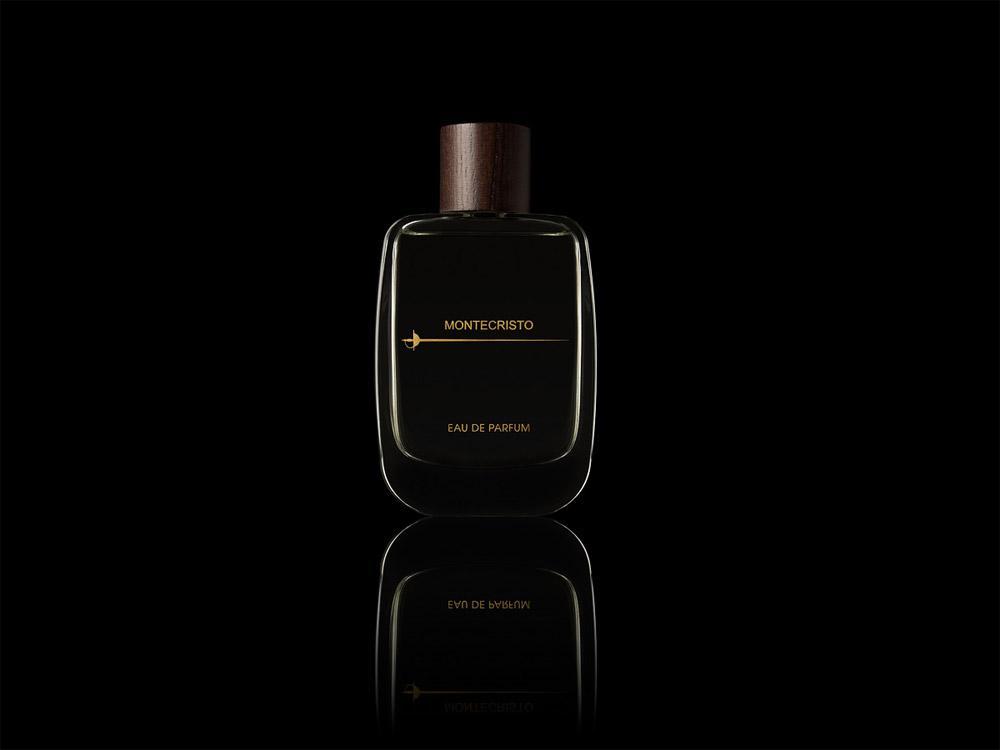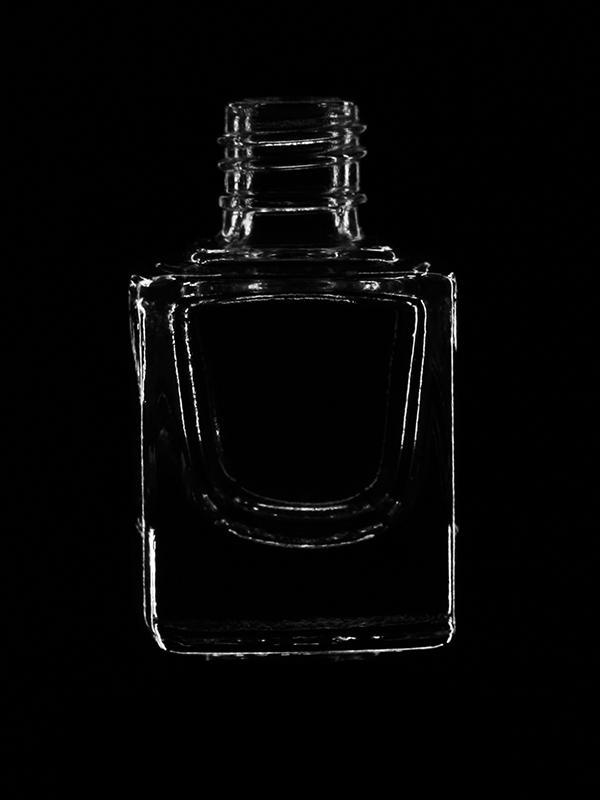The first image is the image on the left, the second image is the image on the right. Assess this claim about the two images: "An image includes a fragrance bottle with a rounded base ad round cap.". Correct or not? Answer yes or no. No. The first image is the image on the left, the second image is the image on the right. For the images shown, is this caption "There are more than two perfume bottles." true? Answer yes or no. No. 